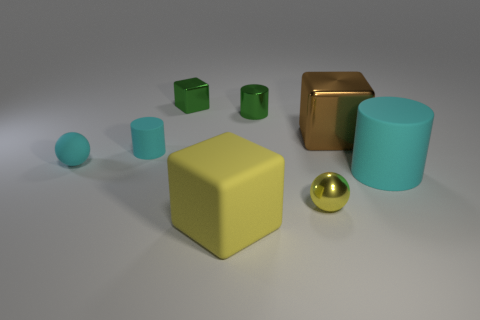Add 2 large shiny objects. How many objects exist? 10 Subtract all cylinders. How many objects are left? 5 Subtract 0 green spheres. How many objects are left? 8 Subtract all tiny cyan matte balls. Subtract all big cubes. How many objects are left? 5 Add 7 shiny spheres. How many shiny spheres are left? 8 Add 3 rubber spheres. How many rubber spheres exist? 4 